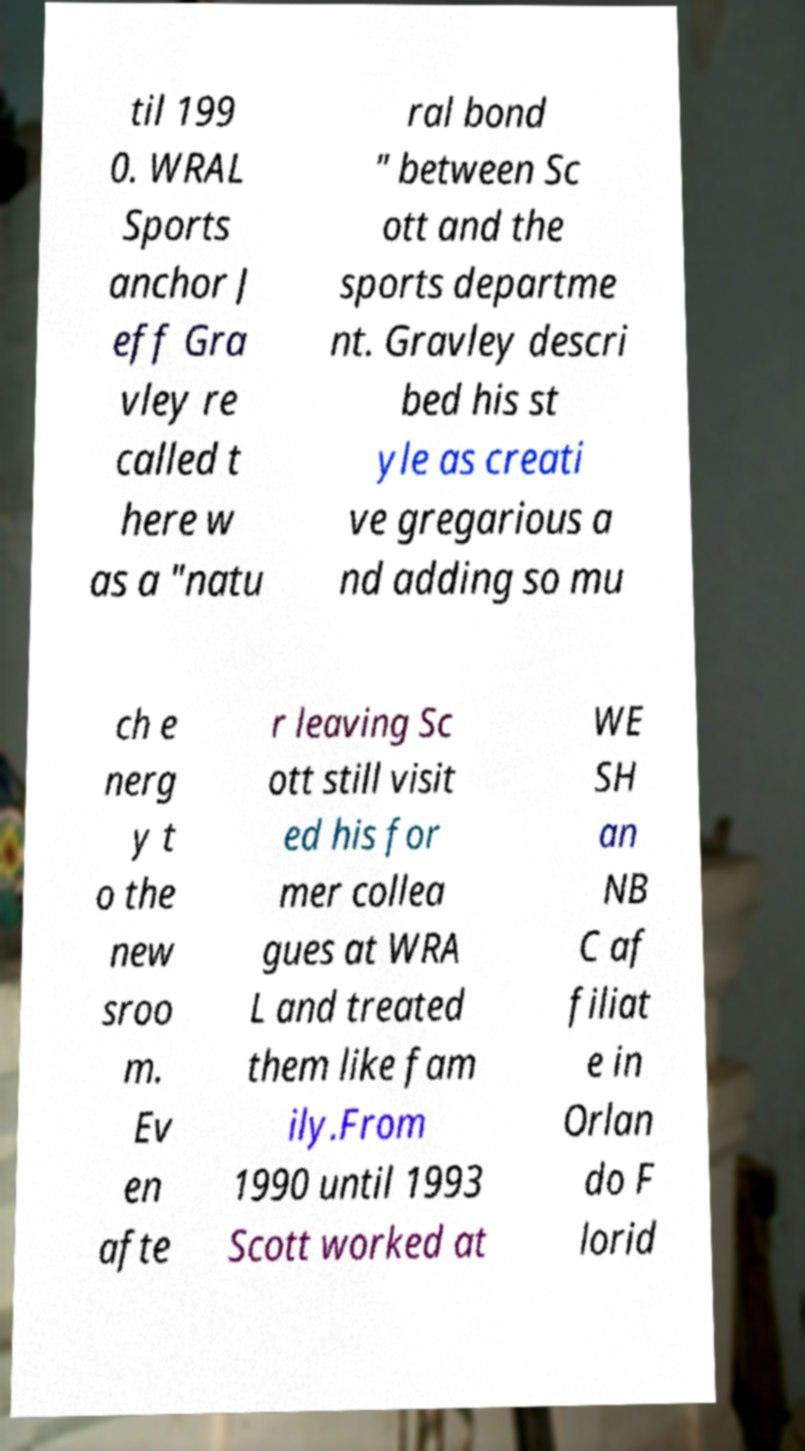Could you assist in decoding the text presented in this image and type it out clearly? til 199 0. WRAL Sports anchor J eff Gra vley re called t here w as a "natu ral bond " between Sc ott and the sports departme nt. Gravley descri bed his st yle as creati ve gregarious a nd adding so mu ch e nerg y t o the new sroo m. Ev en afte r leaving Sc ott still visit ed his for mer collea gues at WRA L and treated them like fam ily.From 1990 until 1993 Scott worked at WE SH an NB C af filiat e in Orlan do F lorid 